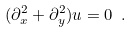<formula> <loc_0><loc_0><loc_500><loc_500>( \partial _ { x } ^ { 2 } + \partial _ { y } ^ { 2 } ) u = 0 \ .</formula> 